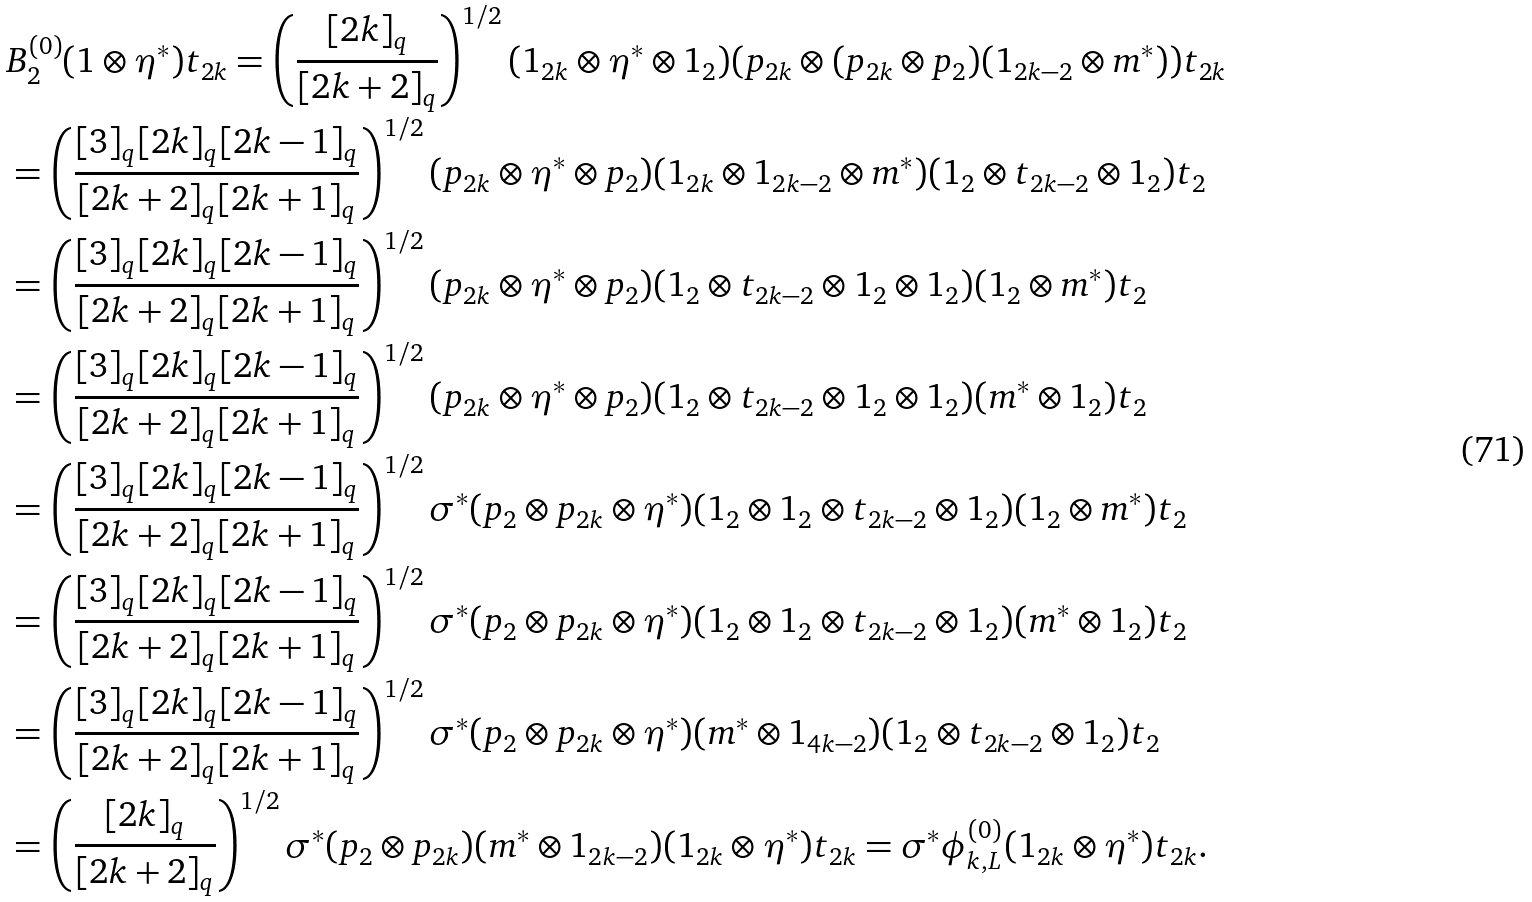<formula> <loc_0><loc_0><loc_500><loc_500>& B _ { 2 } ^ { ( 0 ) } ( 1 \otimes \eta ^ { * } ) t _ { 2 k } = \left ( \frac { [ 2 k ] _ { q } } { [ 2 k + 2 ] _ { q } } \right ) ^ { 1 / 2 } ( 1 _ { 2 k } \otimes \eta ^ { * } \otimes 1 _ { 2 } ) ( p _ { 2 k } \otimes ( p _ { 2 k } \otimes p _ { 2 } ) ( 1 _ { 2 k - 2 } \otimes m ^ { * } ) ) t _ { 2 k } \\ & = \left ( \frac { [ 3 ] _ { q } [ 2 k ] _ { q } [ 2 k - 1 ] _ { q } } { [ 2 k + 2 ] _ { q } [ 2 k + 1 ] _ { q } } \right ) ^ { 1 / 2 } ( p _ { 2 k } \otimes \eta ^ { * } \otimes p _ { 2 } ) ( 1 _ { 2 k } \otimes 1 _ { 2 k - 2 } \otimes m ^ { * } ) ( 1 _ { 2 } \otimes t _ { 2 k - 2 } \otimes 1 _ { 2 } ) t _ { 2 } \\ & = \left ( \frac { [ 3 ] _ { q } [ 2 k ] _ { q } [ 2 k - 1 ] _ { q } } { [ 2 k + 2 ] _ { q } [ 2 k + 1 ] _ { q } } \right ) ^ { 1 / 2 } ( p _ { 2 k } \otimes \eta ^ { * } \otimes p _ { 2 } ) ( 1 _ { 2 } \otimes t _ { 2 k - 2 } \otimes 1 _ { 2 } \otimes 1 _ { 2 } ) ( 1 _ { 2 } \otimes m ^ { * } ) t _ { 2 } \\ & = \left ( \frac { [ 3 ] _ { q } [ 2 k ] _ { q } [ 2 k - 1 ] _ { q } } { [ 2 k + 2 ] _ { q } [ 2 k + 1 ] _ { q } } \right ) ^ { 1 / 2 } ( p _ { 2 k } \otimes \eta ^ { * } \otimes p _ { 2 } ) ( 1 _ { 2 } \otimes t _ { 2 k - 2 } \otimes 1 _ { 2 } \otimes 1 _ { 2 } ) ( m ^ { * } \otimes 1 _ { 2 } ) t _ { 2 } \\ & = \left ( \frac { [ 3 ] _ { q } [ 2 k ] _ { q } [ 2 k - 1 ] _ { q } } { [ 2 k + 2 ] _ { q } [ 2 k + 1 ] _ { q } } \right ) ^ { 1 / 2 } \sigma ^ { * } ( p _ { 2 } \otimes p _ { 2 k } \otimes \eta ^ { * } ) ( 1 _ { 2 } \otimes 1 _ { 2 } \otimes t _ { 2 k - 2 } \otimes 1 _ { 2 } ) ( 1 _ { 2 } \otimes m ^ { * } ) t _ { 2 } \\ & = \left ( \frac { [ 3 ] _ { q } [ 2 k ] _ { q } [ 2 k - 1 ] _ { q } } { [ 2 k + 2 ] _ { q } [ 2 k + 1 ] _ { q } } \right ) ^ { 1 / 2 } \sigma ^ { * } ( p _ { 2 } \otimes p _ { 2 k } \otimes \eta ^ { * } ) ( 1 _ { 2 } \otimes 1 _ { 2 } \otimes t _ { 2 k - 2 } \otimes 1 _ { 2 } ) ( m ^ { * } \otimes 1 _ { 2 } ) t _ { 2 } \\ & = \left ( \frac { [ 3 ] _ { q } [ 2 k ] _ { q } [ 2 k - 1 ] _ { q } } { [ 2 k + 2 ] _ { q } [ 2 k + 1 ] _ { q } } \right ) ^ { 1 / 2 } \sigma ^ { * } ( p _ { 2 } \otimes p _ { 2 k } \otimes \eta ^ { * } ) ( m ^ { * } \otimes 1 _ { 4 k - 2 } ) ( 1 _ { 2 } \otimes t _ { 2 k - 2 } \otimes 1 _ { 2 } ) t _ { 2 } \\ & = \left ( \frac { [ 2 k ] _ { q } } { [ 2 k + 2 ] _ { q } } \right ) ^ { 1 / 2 } \sigma ^ { * } ( p _ { 2 } \otimes p _ { 2 k } ) ( m ^ { * } \otimes 1 _ { 2 k - 2 } ) ( 1 _ { 2 k } \otimes \eta ^ { * } ) t _ { 2 k } = \sigma ^ { * } \phi ^ { ( 0 ) } _ { k , L } ( 1 _ { 2 k } \otimes \eta ^ { * } ) t _ { 2 k } .</formula> 